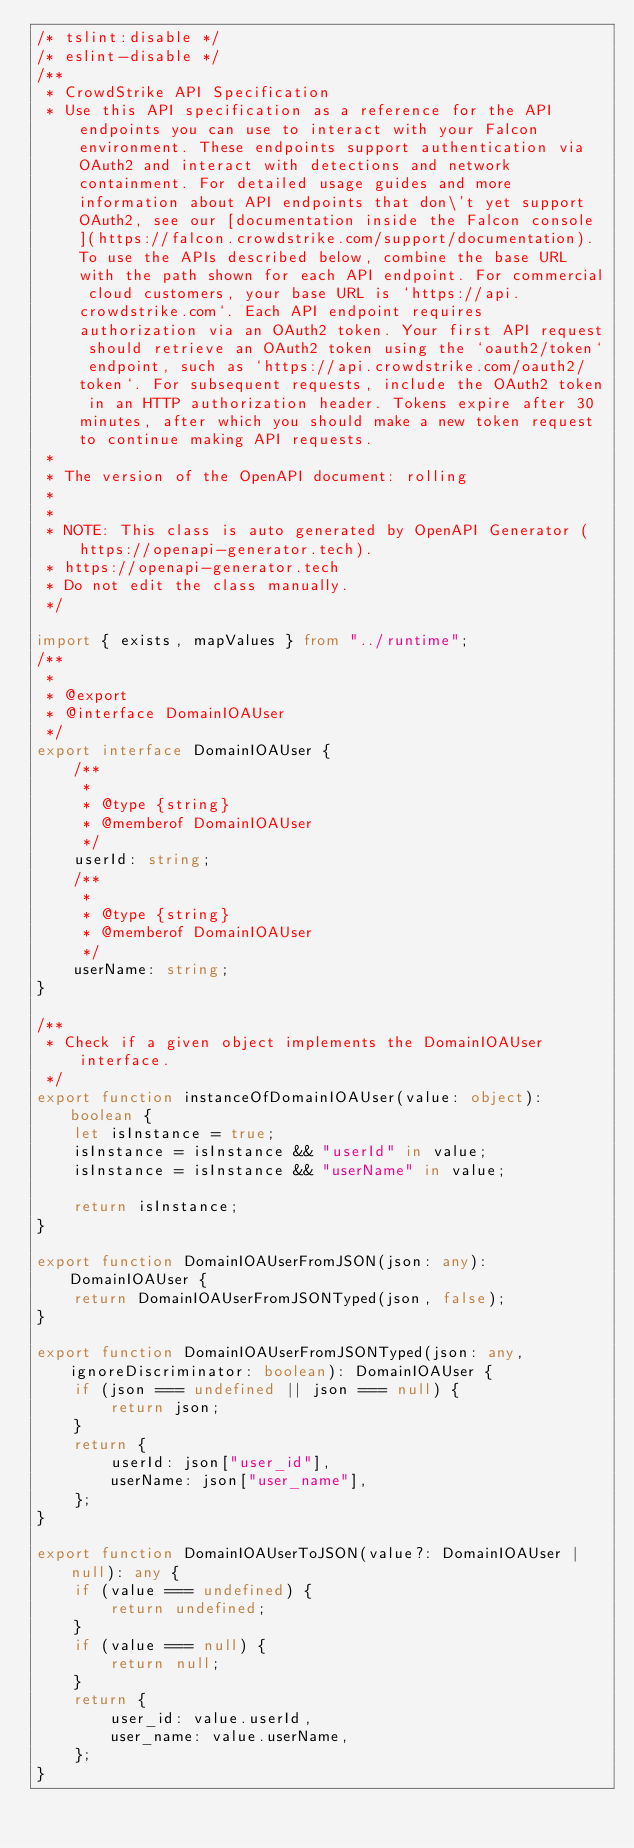Convert code to text. <code><loc_0><loc_0><loc_500><loc_500><_TypeScript_>/* tslint:disable */
/* eslint-disable */
/**
 * CrowdStrike API Specification
 * Use this API specification as a reference for the API endpoints you can use to interact with your Falcon environment. These endpoints support authentication via OAuth2 and interact with detections and network containment. For detailed usage guides and more information about API endpoints that don\'t yet support OAuth2, see our [documentation inside the Falcon console](https://falcon.crowdstrike.com/support/documentation). To use the APIs described below, combine the base URL with the path shown for each API endpoint. For commercial cloud customers, your base URL is `https://api.crowdstrike.com`. Each API endpoint requires authorization via an OAuth2 token. Your first API request should retrieve an OAuth2 token using the `oauth2/token` endpoint, such as `https://api.crowdstrike.com/oauth2/token`. For subsequent requests, include the OAuth2 token in an HTTP authorization header. Tokens expire after 30 minutes, after which you should make a new token request to continue making API requests.
 *
 * The version of the OpenAPI document: rolling
 *
 *
 * NOTE: This class is auto generated by OpenAPI Generator (https://openapi-generator.tech).
 * https://openapi-generator.tech
 * Do not edit the class manually.
 */

import { exists, mapValues } from "../runtime";
/**
 *
 * @export
 * @interface DomainIOAUser
 */
export interface DomainIOAUser {
    /**
     *
     * @type {string}
     * @memberof DomainIOAUser
     */
    userId: string;
    /**
     *
     * @type {string}
     * @memberof DomainIOAUser
     */
    userName: string;
}

/**
 * Check if a given object implements the DomainIOAUser interface.
 */
export function instanceOfDomainIOAUser(value: object): boolean {
    let isInstance = true;
    isInstance = isInstance && "userId" in value;
    isInstance = isInstance && "userName" in value;

    return isInstance;
}

export function DomainIOAUserFromJSON(json: any): DomainIOAUser {
    return DomainIOAUserFromJSONTyped(json, false);
}

export function DomainIOAUserFromJSONTyped(json: any, ignoreDiscriminator: boolean): DomainIOAUser {
    if (json === undefined || json === null) {
        return json;
    }
    return {
        userId: json["user_id"],
        userName: json["user_name"],
    };
}

export function DomainIOAUserToJSON(value?: DomainIOAUser | null): any {
    if (value === undefined) {
        return undefined;
    }
    if (value === null) {
        return null;
    }
    return {
        user_id: value.userId,
        user_name: value.userName,
    };
}
</code> 